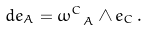<formula> <loc_0><loc_0><loc_500><loc_500>d e _ { A } = \omega _ { \ A } ^ { C } \wedge e _ { C } \, .</formula> 